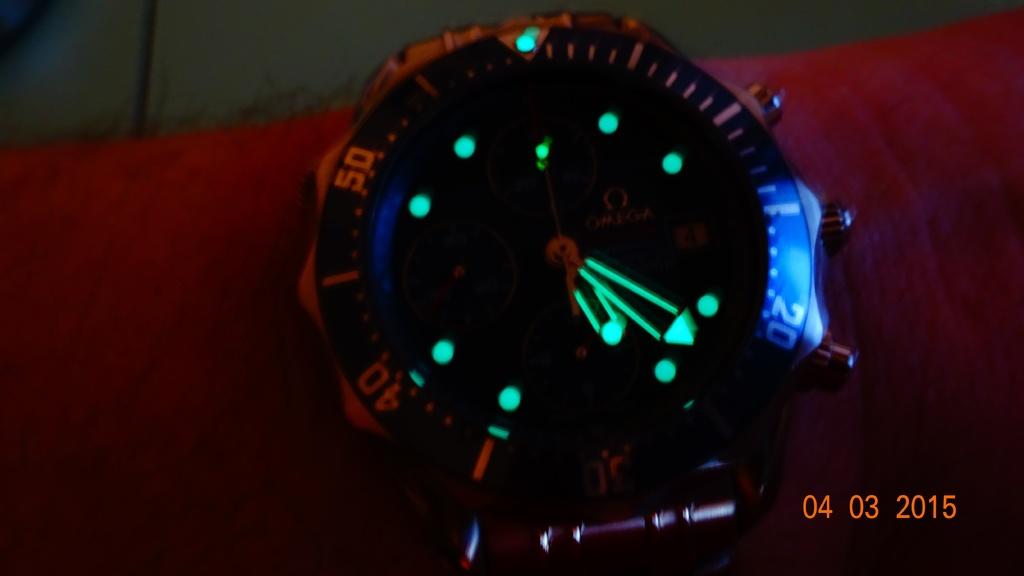When was this picture taken?
Provide a succinct answer. 04 03 2015. What date was this picture taken?
Your answer should be very brief. 04/03/2015. 